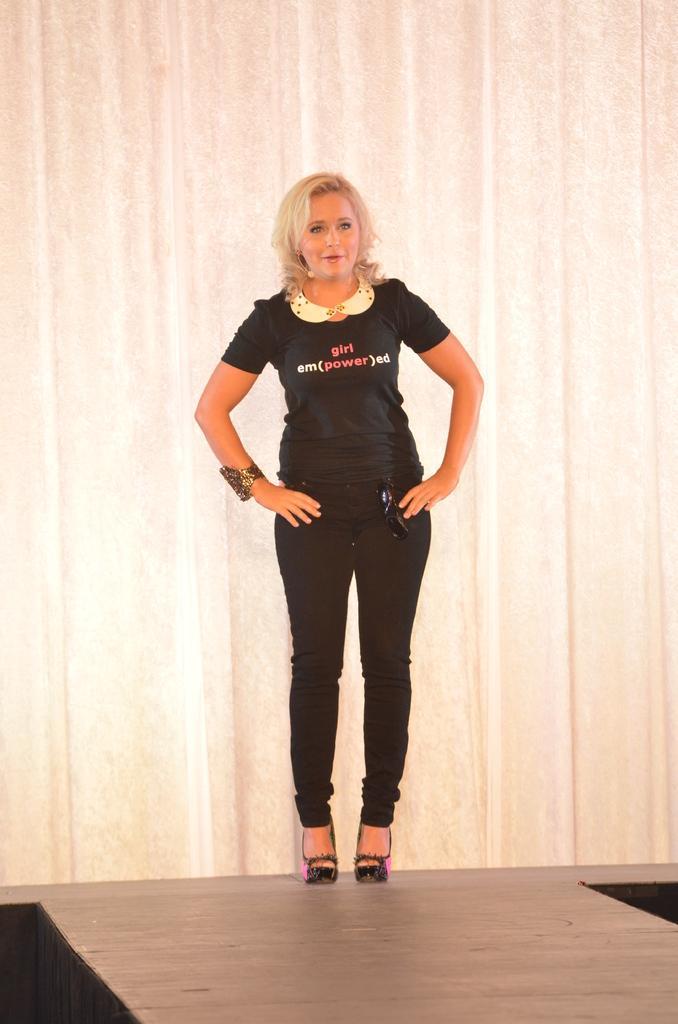In one or two sentences, can you explain what this image depicts? This image consists of a woman. She is wearing a black T-shirt and a black pant. At the bottom, there is a floor. In the background, there is a wall. 